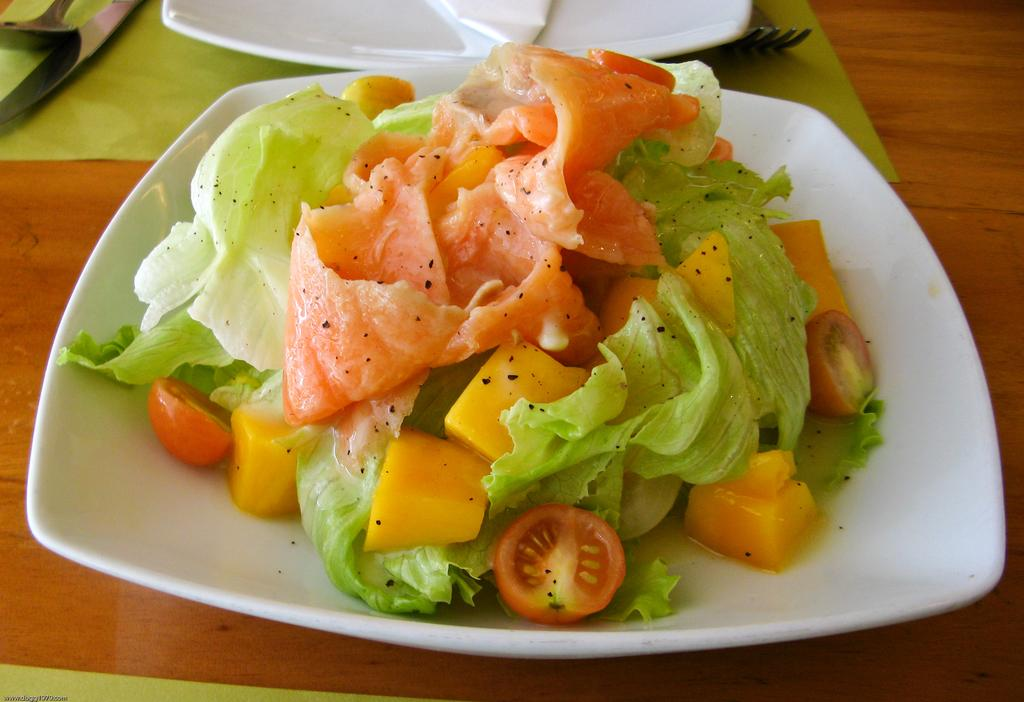What type of food is on the plate in the image? There is a salad on a white color plate in the image. Where is the plate placed? The plate is placed on a wooden surface. Are there any other plates visible in the image? Yes, there is another plate in the image. What utensils are present in the image? A fork, a knife, and a spoon are present in the image. What type of dolls are sitting on the wooden surface in the image? There are no dolls present in the image; it features a salad on a plate placed on a wooden surface. 